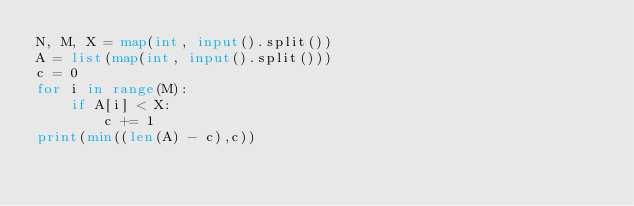<code> <loc_0><loc_0><loc_500><loc_500><_Python_>N, M, X = map(int, input().split())
A = list(map(int, input().split()))
c = 0
for i in range(M):
    if A[i] < X:
        c += 1
print(min((len(A) - c),c))
</code> 